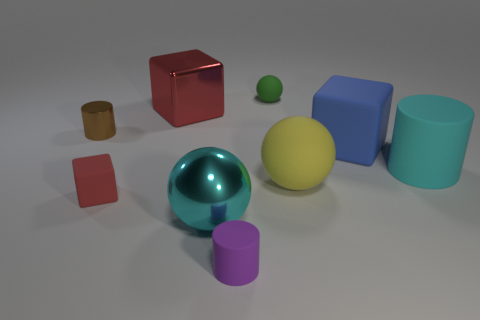What material is the object that is the same color as the big cylinder?
Make the answer very short. Metal. Are there any cyan objects that have the same material as the green object?
Your response must be concise. Yes. Do the matte object that is behind the red metal block and the big blue matte thing have the same size?
Your answer should be compact. No. There is a big cyan thing that is on the right side of the tiny thing behind the tiny brown thing; is there a large metal object that is behind it?
Provide a succinct answer. Yes. What number of matte things are brown things or small cyan cubes?
Ensure brevity in your answer.  0. How many other objects are there of the same shape as the big blue matte object?
Ensure brevity in your answer.  2. Is the number of small green spheres greater than the number of rubber cubes?
Your answer should be compact. No. There is a cyan thing in front of the red object in front of the yellow sphere right of the red rubber cube; what size is it?
Make the answer very short. Large. What is the size of the metal thing behind the small brown cylinder?
Provide a succinct answer. Large. What number of objects are small matte things or large cyan objects behind the small block?
Provide a succinct answer. 4. 